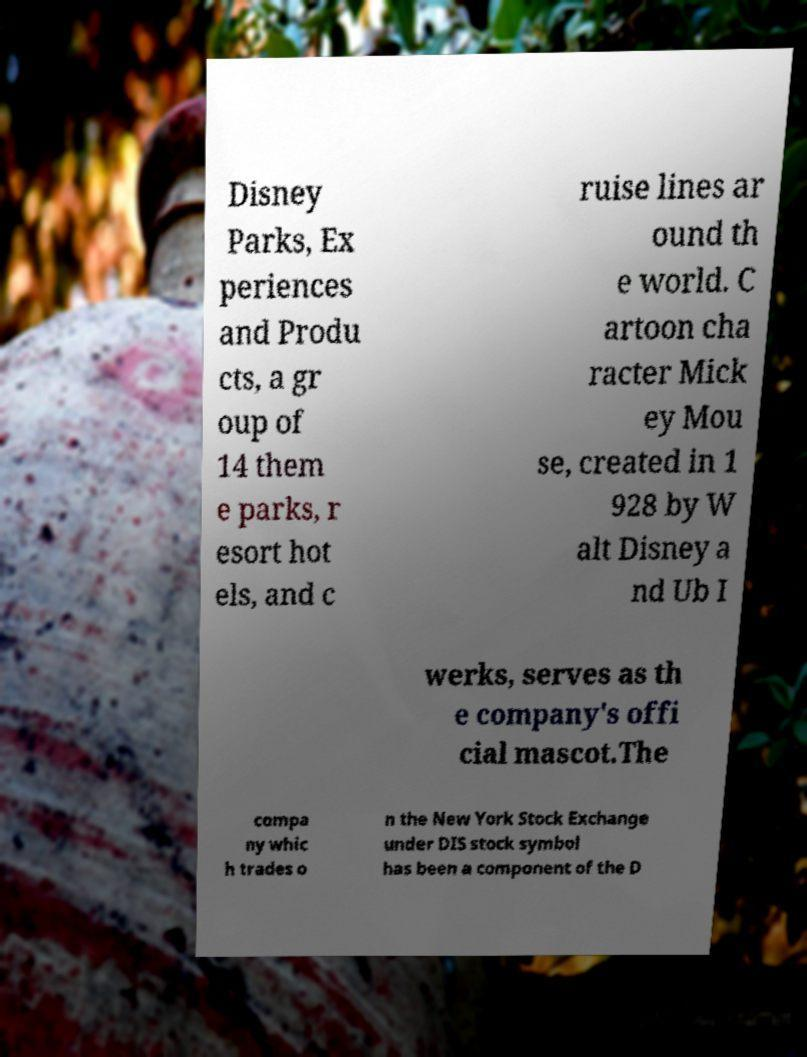What messages or text are displayed in this image? I need them in a readable, typed format. Disney Parks, Ex periences and Produ cts, a gr oup of 14 them e parks, r esort hot els, and c ruise lines ar ound th e world. C artoon cha racter Mick ey Mou se, created in 1 928 by W alt Disney a nd Ub I werks, serves as th e company's offi cial mascot.The compa ny whic h trades o n the New York Stock Exchange under DIS stock symbol has been a component of the D 